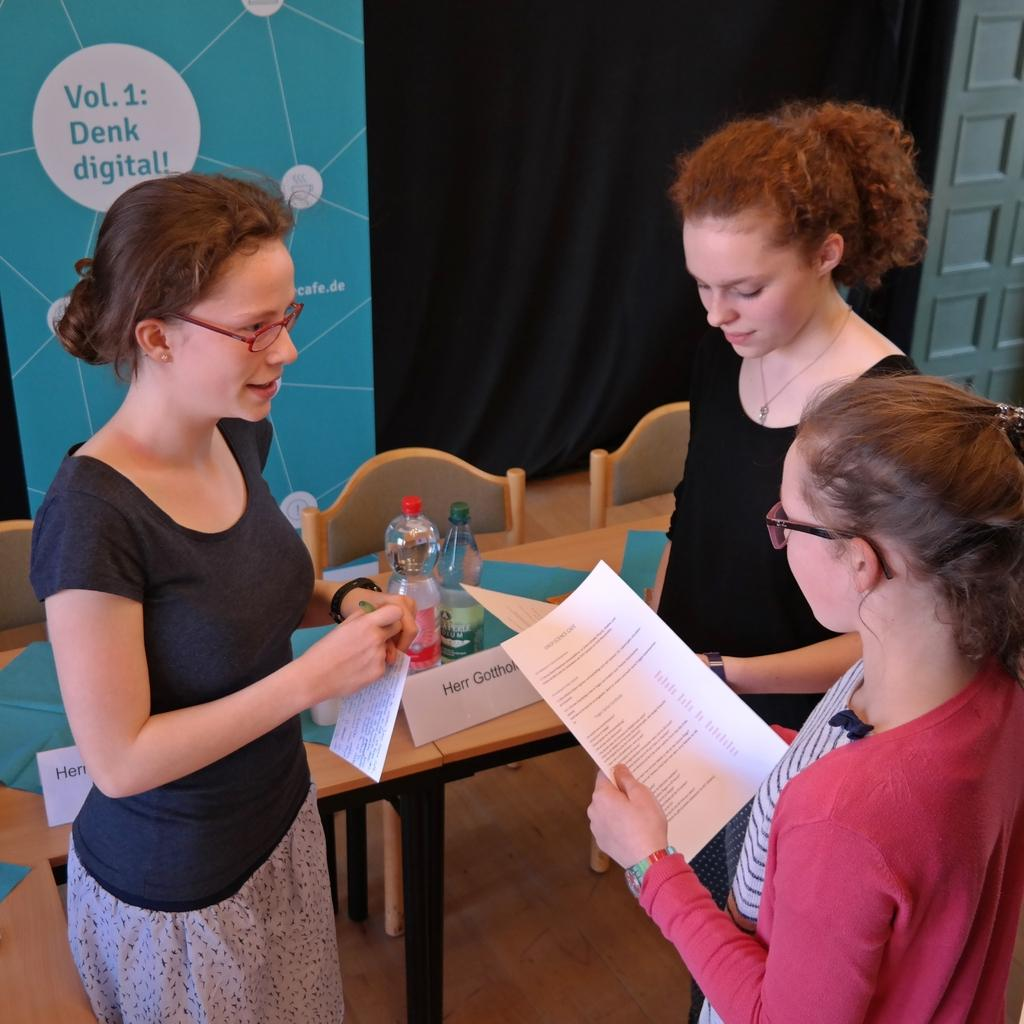How many women are in the image? There are three women in the image. What are the women doing in the image? The women are standing and holding papers in their hands. What can be seen in the background of the image? There is a banner, a cloth, a table, water bottles, and chairs in the background of the image. What type of cream can be seen on the table in the image? There is no cream visible on the table in the image. What property is being discussed by the women in the image? The image does not provide any information about a property being discussed by the women. 